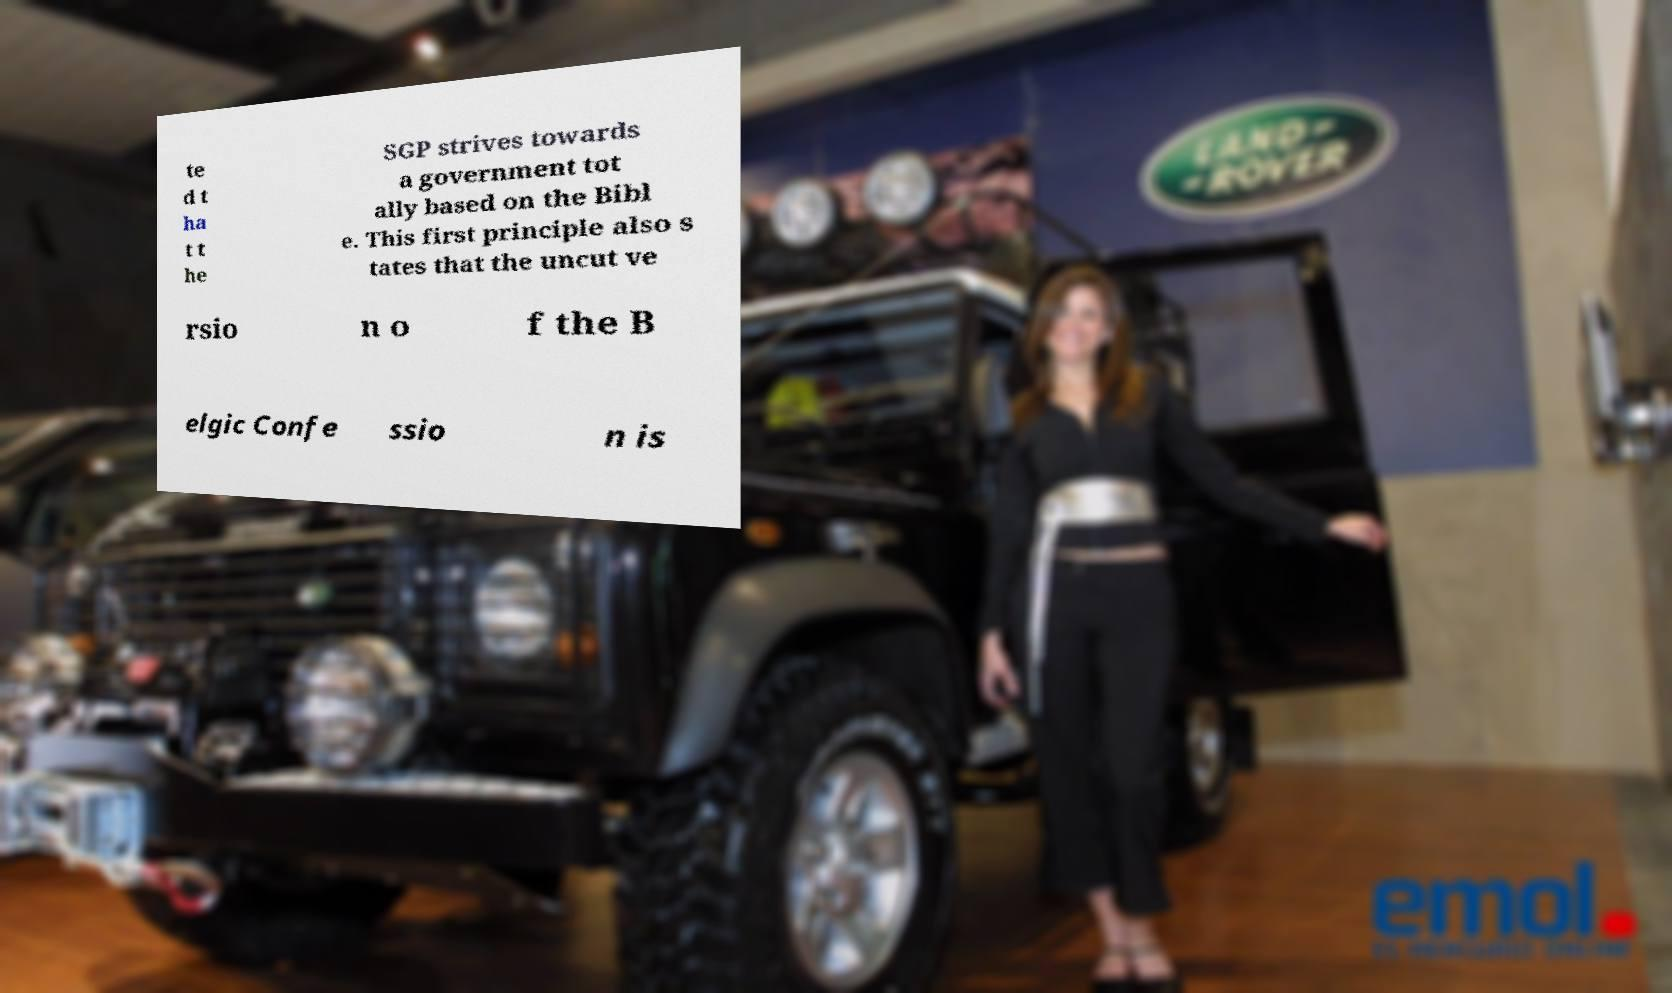Can you accurately transcribe the text from the provided image for me? te d t ha t t he SGP strives towards a government tot ally based on the Bibl e. This first principle also s tates that the uncut ve rsio n o f the B elgic Confe ssio n is 